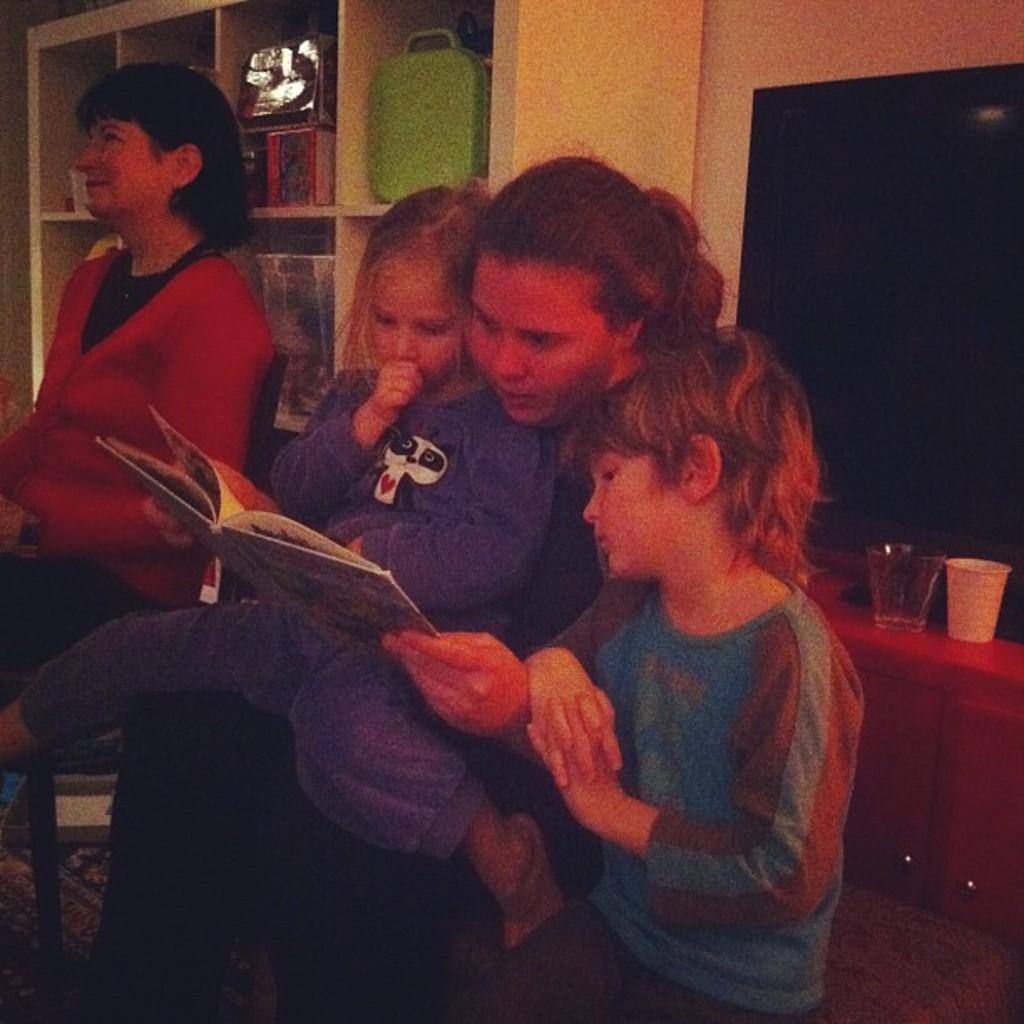Could you give a brief overview of what you see in this image? In the image there is a woman sitting in the front with a girl sitting over her holding a book and a boy sitting on right side of her, on left side there is another woman sitting on chair, in the back there is a tv on the right side on a table with glasses in front of it and on the left side there are shelves on the wall. 